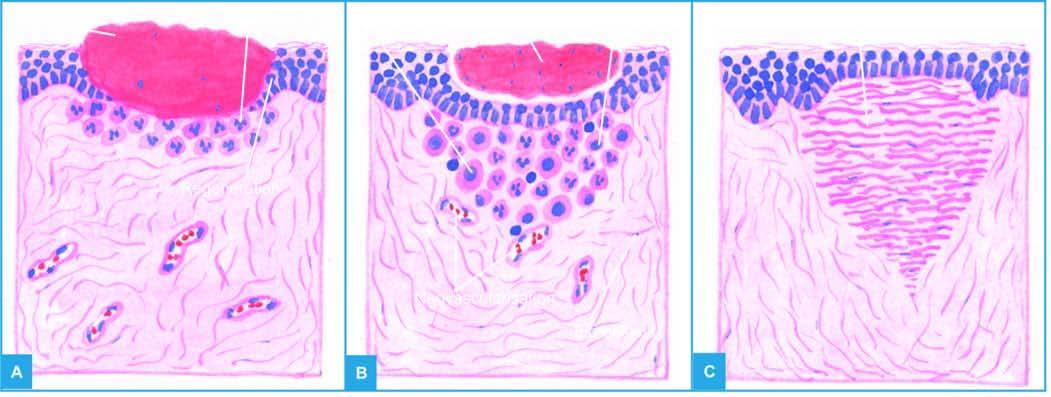s a scar smaller than the original wound left after contraction of the wound?
Answer the question using a single word or phrase. Yes 